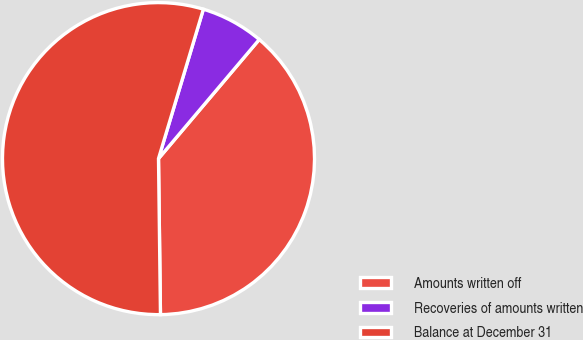<chart> <loc_0><loc_0><loc_500><loc_500><pie_chart><fcel>Amounts written off<fcel>Recoveries of amounts written<fcel>Balance at December 31<nl><fcel>38.63%<fcel>6.53%<fcel>54.85%<nl></chart> 